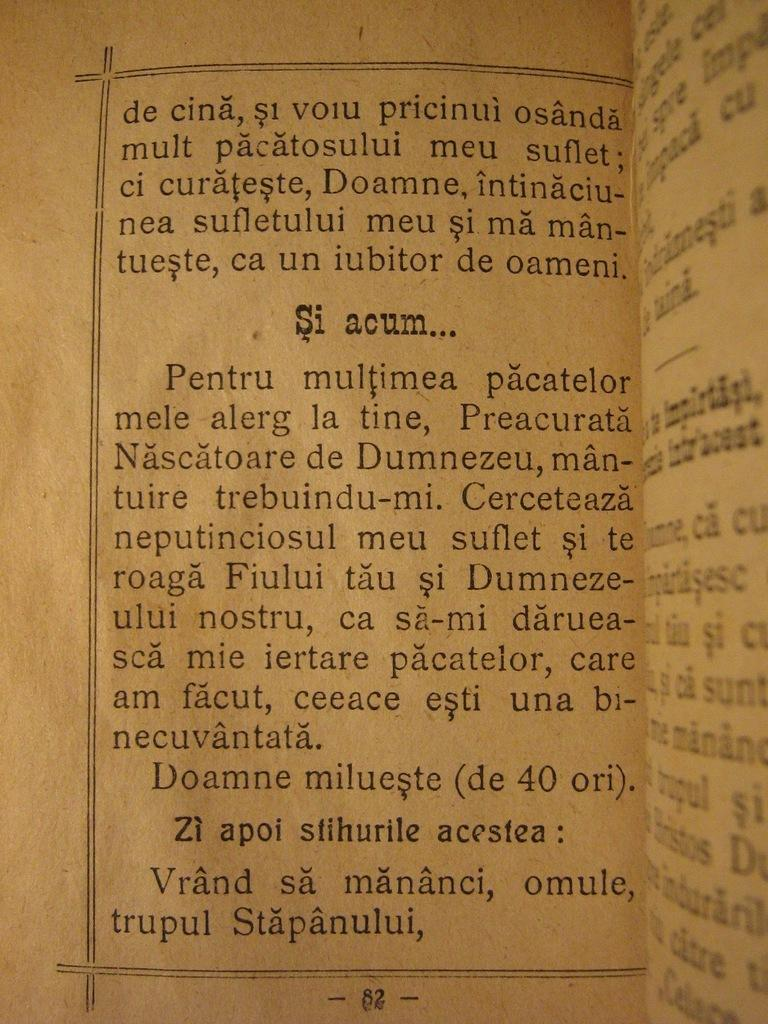What is the color of the paper in the image? The paper in the image is brown. What is used to write on the paper? Something is written on the paper with a black color pen. What is the reason for the distribution of the day in the image? There is no mention of a day or distribution in the image; it only features a brown paper with something written on it using a black color pen. 